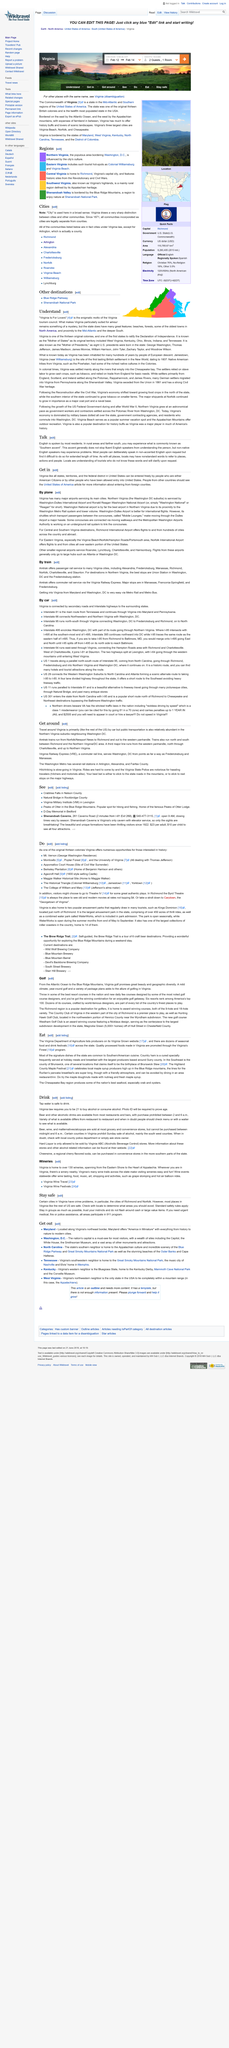Indicate a few pertinent items in this graphic. English is the language spoken by the majority of residents. Locals may use nonstandard words to refer to places, actions, and people, which is a characteristic of their language. Virginia can only be accessed by individuals who are either American citizens or those who have been granted entry into the United States. 